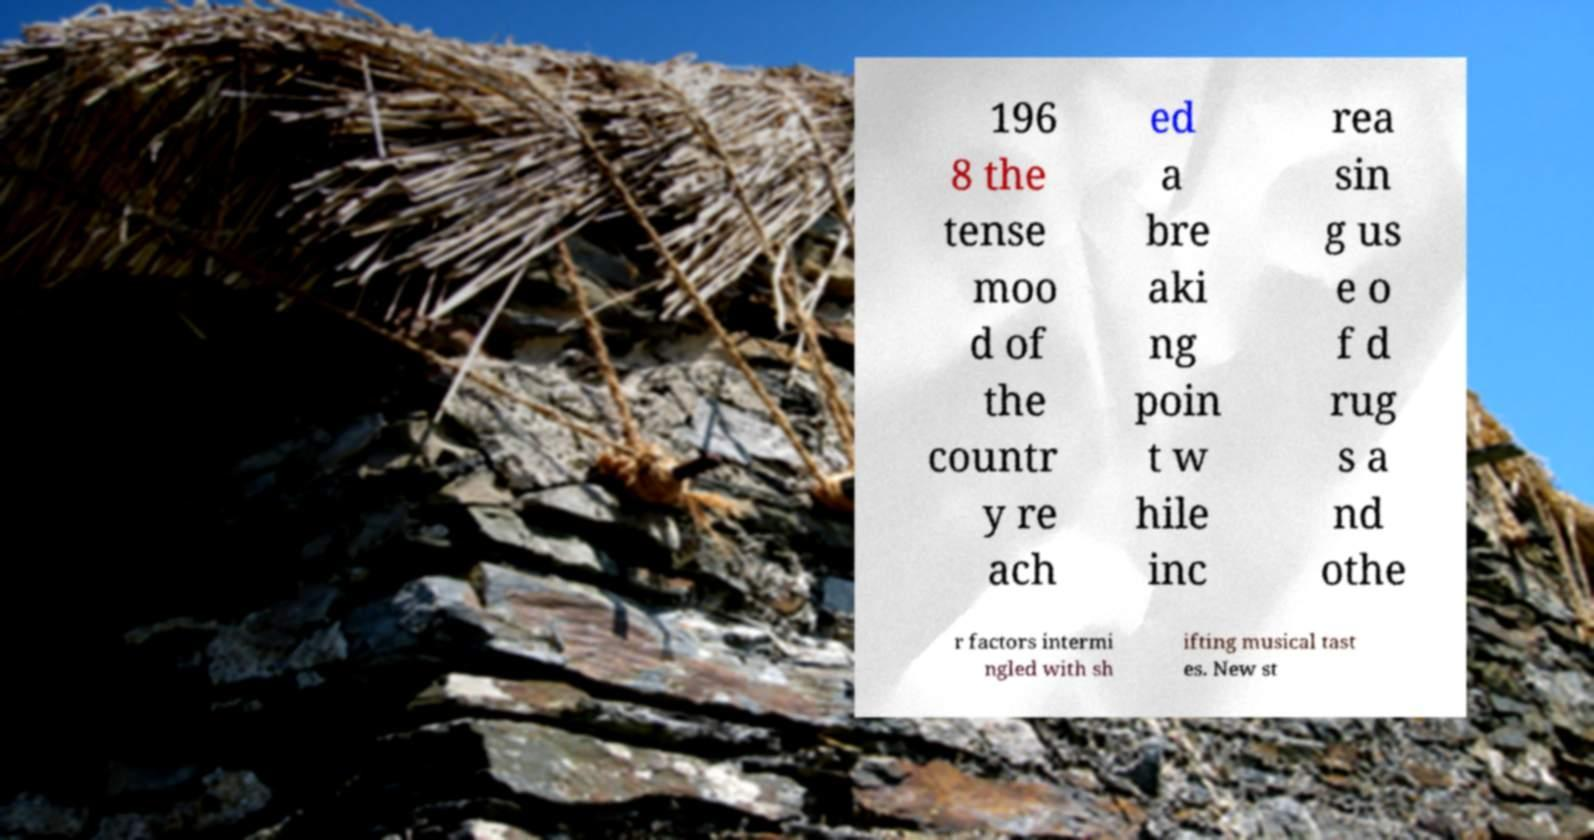I need the written content from this picture converted into text. Can you do that? 196 8 the tense moo d of the countr y re ach ed a bre aki ng poin t w hile inc rea sin g us e o f d rug s a nd othe r factors intermi ngled with sh ifting musical tast es. New st 